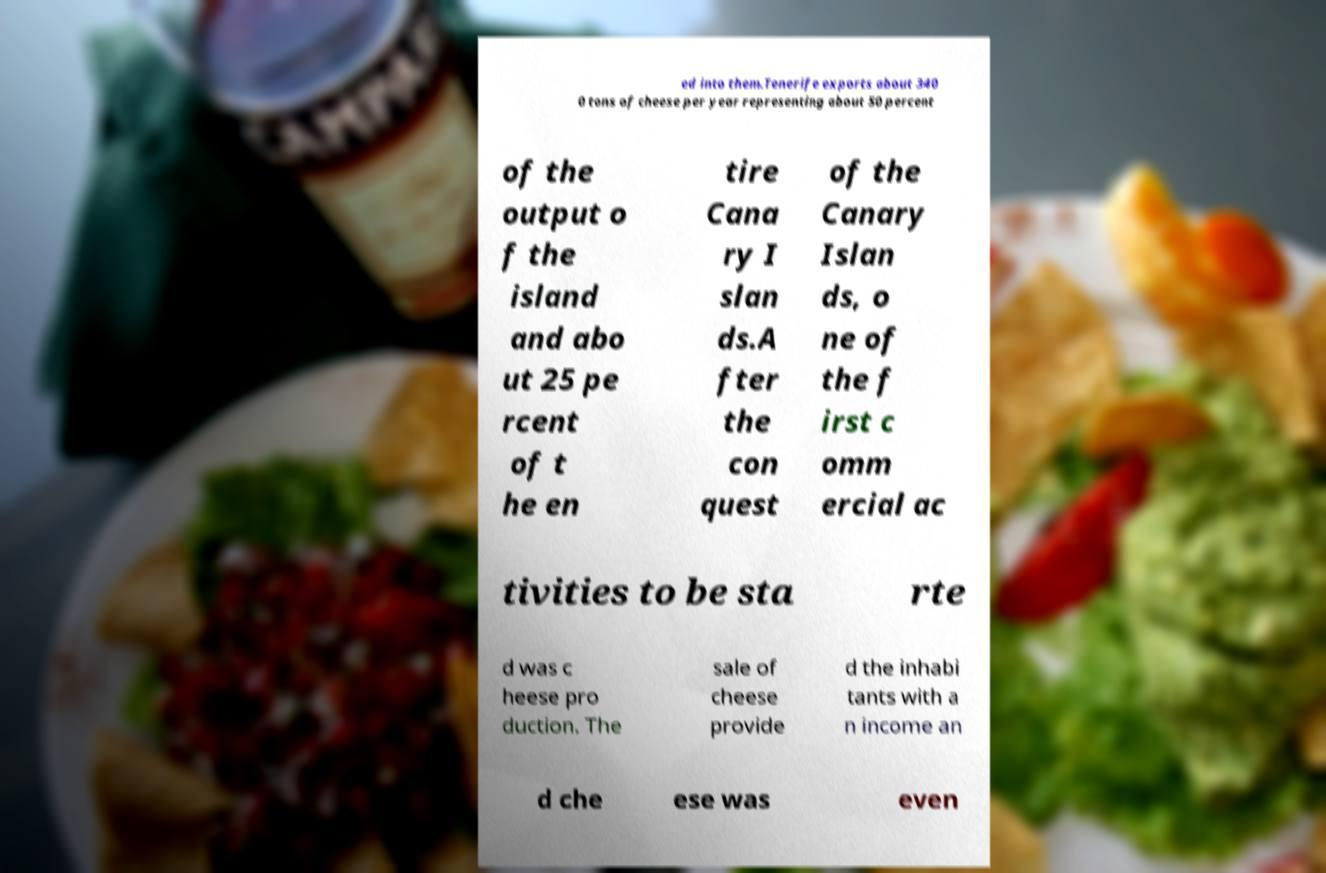Can you accurately transcribe the text from the provided image for me? ed into them.Tenerife exports about 340 0 tons of cheese per year representing about 50 percent of the output o f the island and abo ut 25 pe rcent of t he en tire Cana ry I slan ds.A fter the con quest of the Canary Islan ds, o ne of the f irst c omm ercial ac tivities to be sta rte d was c heese pro duction. The sale of cheese provide d the inhabi tants with a n income an d che ese was even 